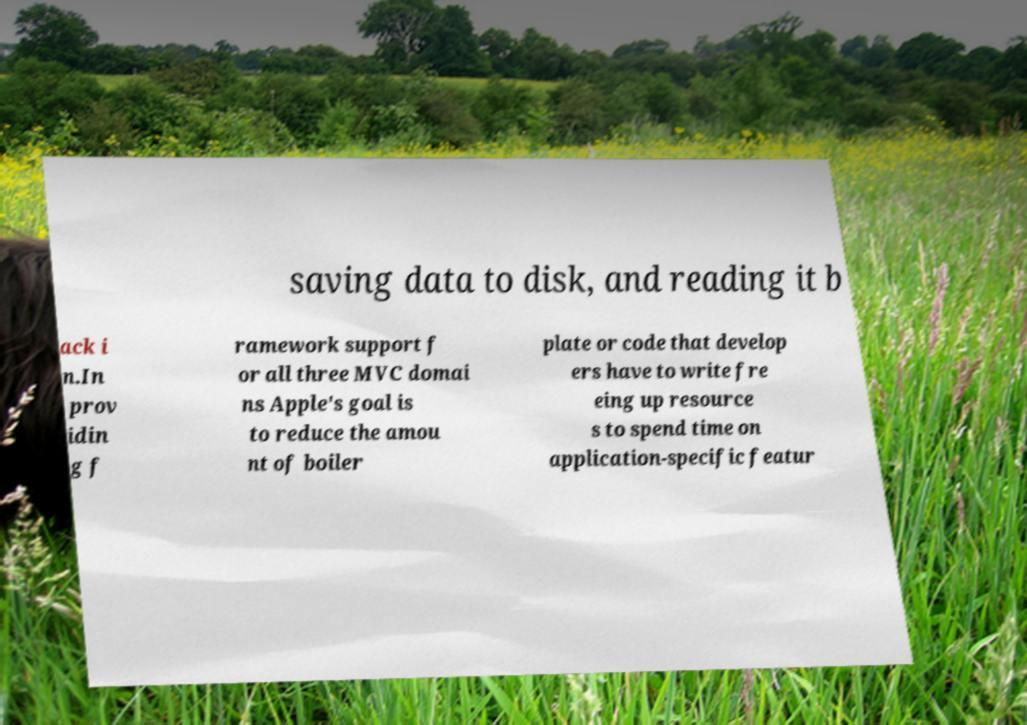Can you accurately transcribe the text from the provided image for me? saving data to disk, and reading it b ack i n.In prov idin g f ramework support f or all three MVC domai ns Apple's goal is to reduce the amou nt of boiler plate or code that develop ers have to write fre eing up resource s to spend time on application-specific featur 